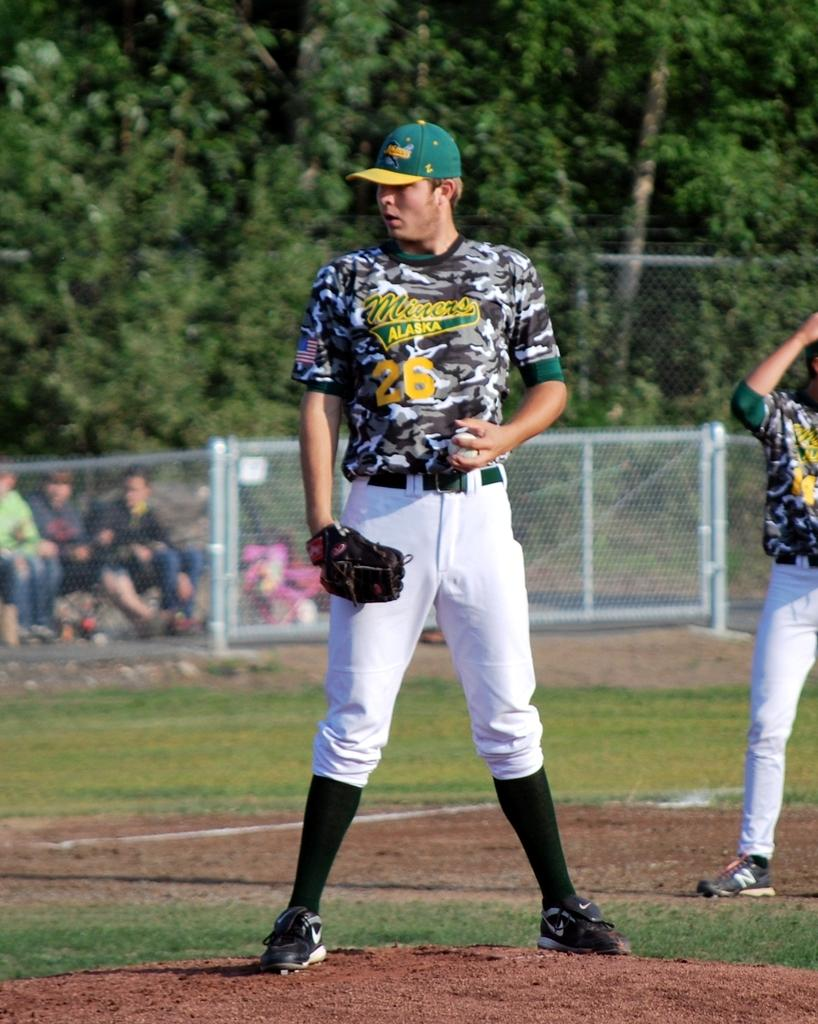Provide a one-sentence caption for the provided image. A player from the Miners baseball team in Alaska stands on the field's mound. 